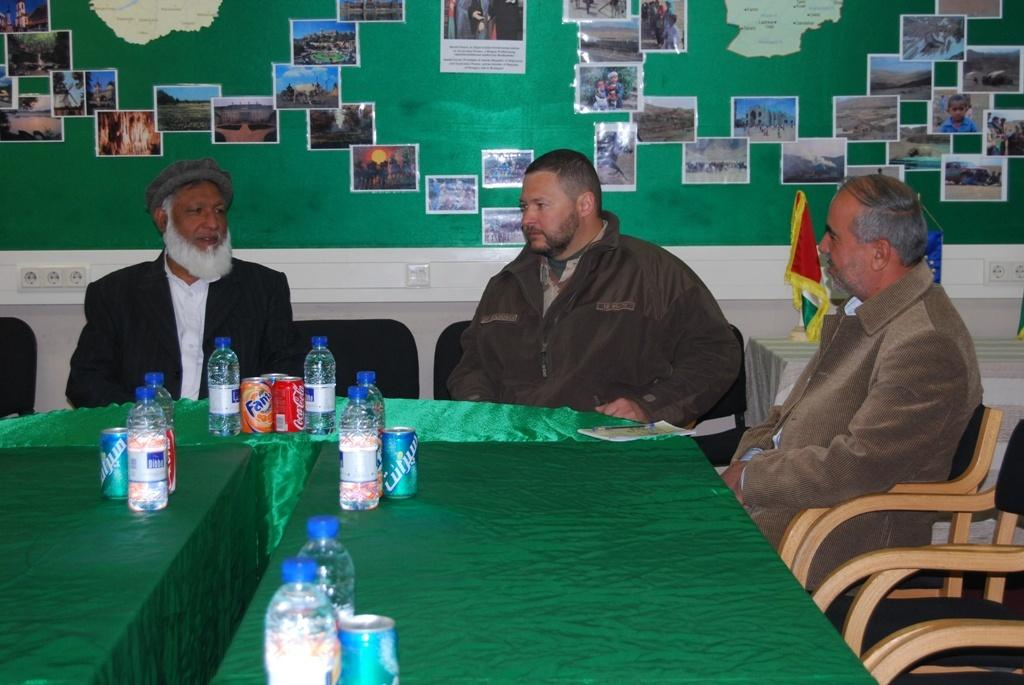How many people are in the image? There are three persons in the image. What are the persons doing in the image? The persons are sitting on chairs. What is present on the table in the image? There are bottles and tins on the table. What can be seen in the background of the image? There is a wall in the background of the image, and there are posters on the wall. What type of card is being used to fix the error in the image? There is no card or error present in the image; it features three people sitting on chairs with a table and posters in the background. 